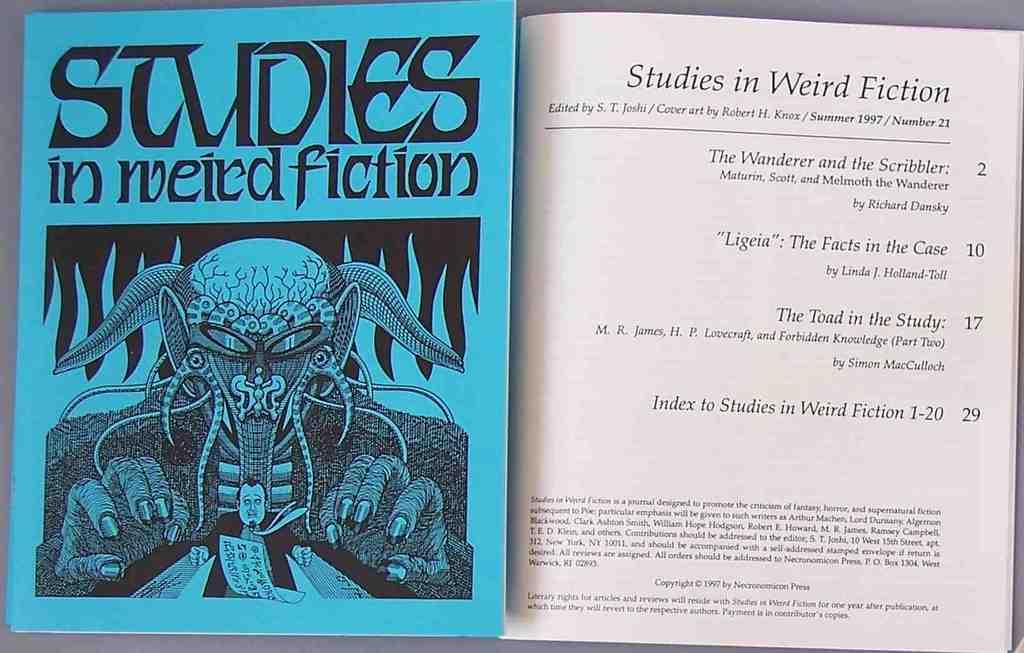Provide a one-sentence caption for the provided image. a book that is titled 'studies in weird fiction'. 